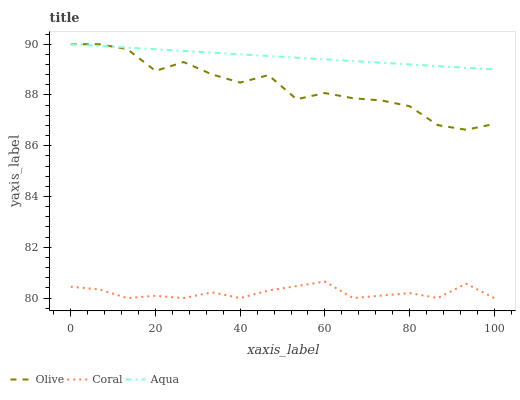Does Coral have the minimum area under the curve?
Answer yes or no. Yes. Does Aqua have the maximum area under the curve?
Answer yes or no. Yes. Does Aqua have the minimum area under the curve?
Answer yes or no. No. Does Coral have the maximum area under the curve?
Answer yes or no. No. Is Aqua the smoothest?
Answer yes or no. Yes. Is Olive the roughest?
Answer yes or no. Yes. Is Coral the smoothest?
Answer yes or no. No. Is Coral the roughest?
Answer yes or no. No. Does Aqua have the lowest value?
Answer yes or no. No. Does Aqua have the highest value?
Answer yes or no. Yes. Does Coral have the highest value?
Answer yes or no. No. Is Coral less than Aqua?
Answer yes or no. Yes. Is Olive greater than Coral?
Answer yes or no. Yes. Does Aqua intersect Olive?
Answer yes or no. Yes. Is Aqua less than Olive?
Answer yes or no. No. Is Aqua greater than Olive?
Answer yes or no. No. Does Coral intersect Aqua?
Answer yes or no. No. 